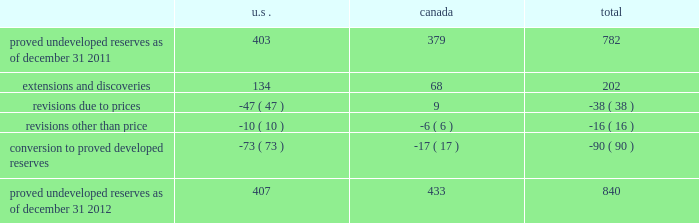Devon energy corporation and subsidiaries notes to consolidated financial statements 2013 ( continued ) proved undeveloped reserves the table presents the changes in devon 2019s total proved undeveloped reserves during 2012 ( in mmboe ) . .
At december 31 , 2012 , devon had 840 mmboe of proved undeveloped reserves .
This represents a 7 percent increase as compared to 2011 and represents 28 percent of its total proved reserves .
Drilling and development activities increased devon 2019s proved undeveloped reserves 203 mmboe and resulted in the conversion of 90 mmboe , or 12 percent , of the 2011 proved undeveloped reserves to proved developed reserves .
Costs incurred related to the development and conversion of devon 2019s proved undeveloped reserves were $ 1.3 billion for 2012 .
Additionally , revisions other than price decreased devon 2019s proved undeveloped reserves 16 mmboe primarily due to its evaluation of certain u.s .
Onshore dry-gas areas , which it does not expect to develop in the next five years .
The largest revisions relate to the dry-gas areas at carthage in east texas and the barnett shale in north texas .
A significant amount of devon 2019s proved undeveloped reserves at the end of 2012 largely related to its jackfish operations .
At december 31 , 2012 and 2011 , devon 2019s jackfish proved undeveloped reserves were 429 mmboe and 367 mmboe , respectively .
Development schedules for the jackfish reserves are primarily controlled by the need to keep the processing plants at their 35000 barrel daily facility capacity .
Processing plant capacity is controlled by factors such as total steam processing capacity , steam-oil ratios and air quality discharge permits .
As a result , these reserves are classified as proved undeveloped for more than five years .
Currently , the development schedule for these reserves extends though the year 2031 .
Price revisions 2012 - reserves decreased 171 mmboe primarily due to lower gas prices .
Of this decrease , 100 mmboe related to the barnett shale and 25 mmboe related to the rocky mountain area .
2011 - reserves decreased 21 mmboe due to lower gas prices and higher oil prices .
The higher oil prices increased devon 2019s canadian royalty burden , which reduced devon 2019s oil reserves .
2010 - reserves increased 72 mmboe due to higher gas prices , partially offset by the effect of higher oil prices .
The higher oil prices increased devon 2019s canadian royalty burden , which reduced devon 2019s oil reserves .
Of the 72 mmboe price revisions , 43 mmboe related to the barnett shale and 22 mmboe related to the rocky mountain area .
Revisions other than price total revisions other than price for 2012 and 2011 primarily related to devon 2019s evaluation of certain dry gas regions noted in the proved undeveloped reserves discussion above .
Total revisions other than price for 2010 primarily related to devon 2019s drilling and development in the barnett shale. .
What was the percent of the proved undeveloped reserves as of december 31 2011 in the us? 
Computations: (403 / 782)
Answer: 0.51535. 